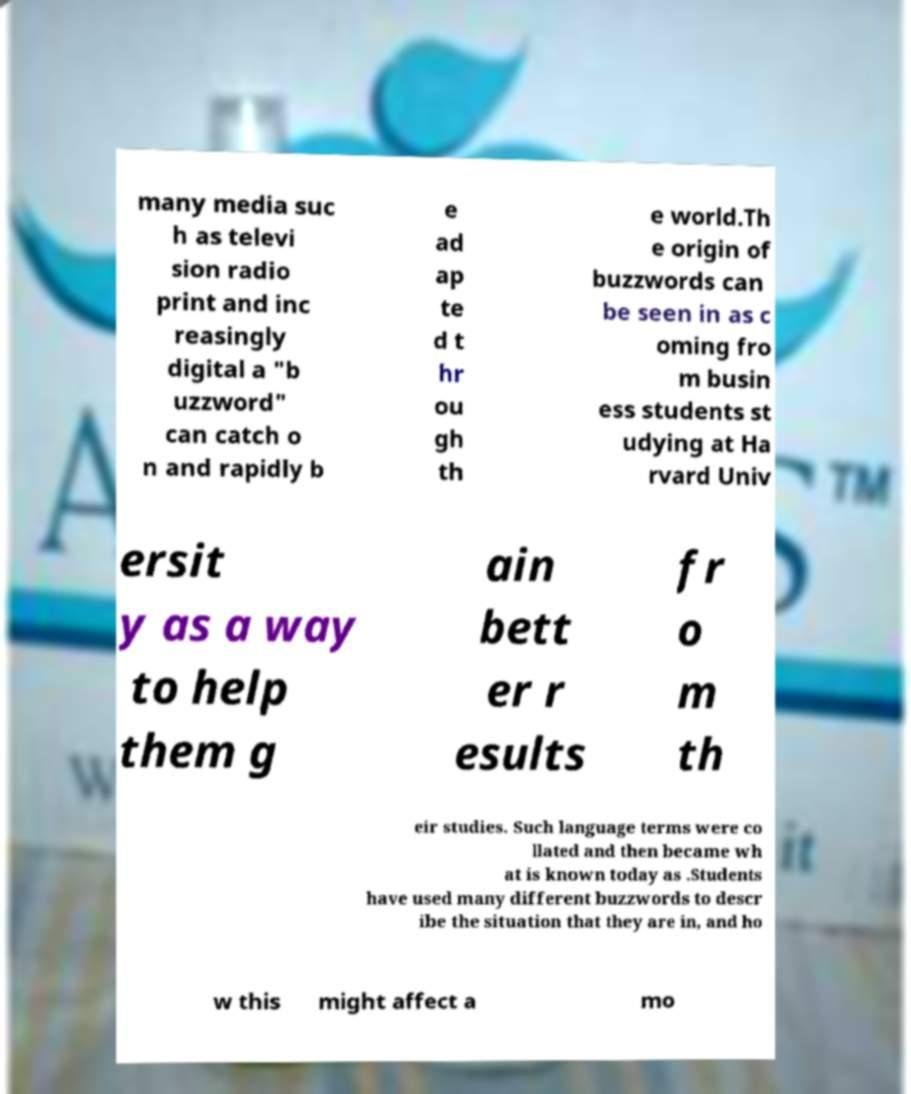Please identify and transcribe the text found in this image. many media suc h as televi sion radio print and inc reasingly digital a "b uzzword" can catch o n and rapidly b e ad ap te d t hr ou gh th e world.Th e origin of buzzwords can be seen in as c oming fro m busin ess students st udying at Ha rvard Univ ersit y as a way to help them g ain bett er r esults fr o m th eir studies. Such language terms were co llated and then became wh at is known today as .Students have used many different buzzwords to descr ibe the situation that they are in, and ho w this might affect a mo 